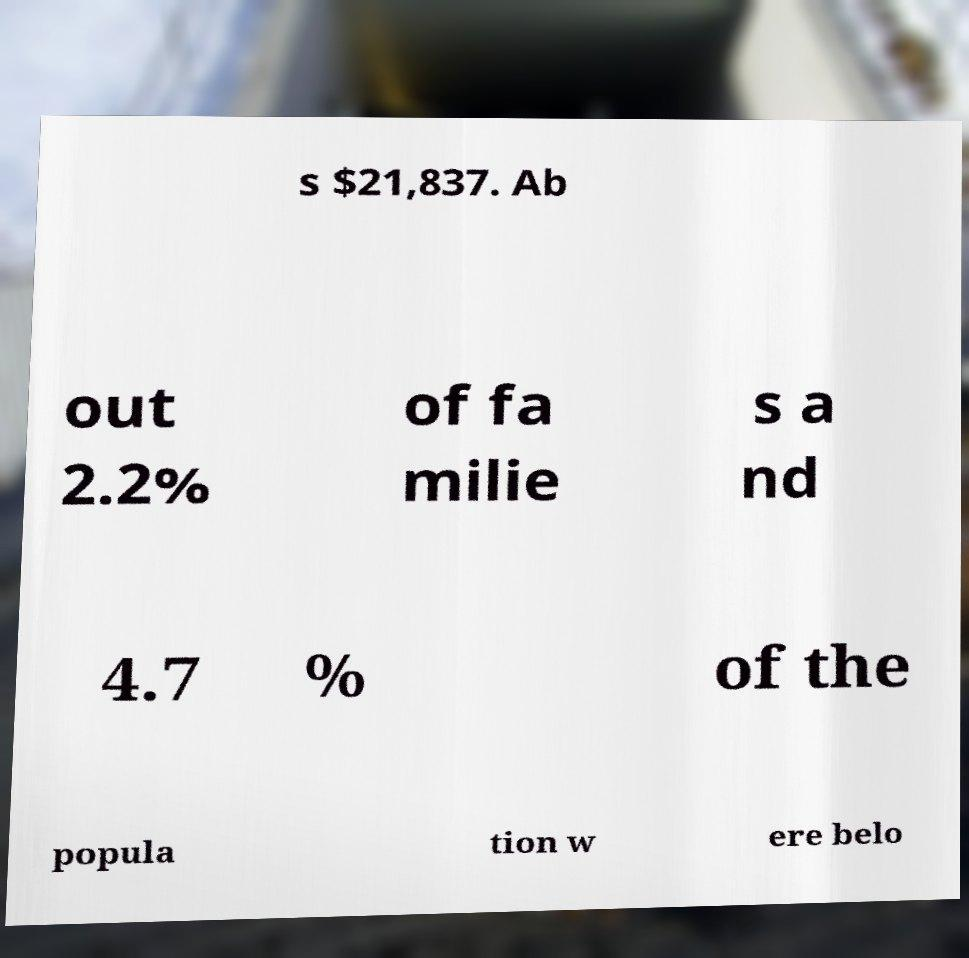Can you accurately transcribe the text from the provided image for me? s $21,837. Ab out 2.2% of fa milie s a nd 4.7 % of the popula tion w ere belo 